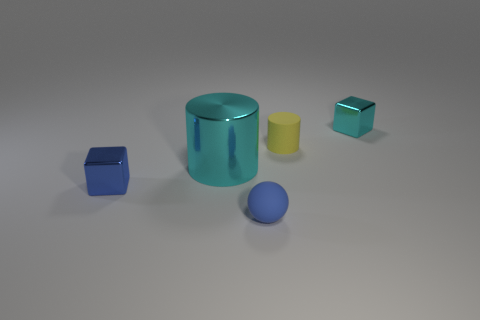What is the shape of the yellow thing that is the same size as the rubber sphere?
Give a very brief answer. Cylinder. How many things are either small cyan blocks or tiny blocks that are behind the yellow rubber cylinder?
Offer a very short reply. 1. How many tiny cubes are in front of the metallic cube that is to the right of the block left of the tiny cyan cube?
Your answer should be very brief. 1. There is a cylinder that is made of the same material as the blue block; what color is it?
Offer a terse response. Cyan. There is a metal object that is to the right of the cyan shiny cylinder; does it have the same size as the shiny cylinder?
Offer a very short reply. No. What number of objects are either tiny rubber cylinders or large cyan objects?
Your response must be concise. 2. What is the tiny blue object that is to the left of the matte object that is in front of the metal cube in front of the small cyan metallic cube made of?
Provide a short and direct response. Metal. There is a blue thing that is to the left of the tiny matte sphere; what is it made of?
Make the answer very short. Metal. Are there any metallic balls of the same size as the yellow rubber object?
Offer a terse response. No. Does the tiny metal object that is to the right of the small matte ball have the same color as the tiny rubber ball?
Provide a short and direct response. No. 